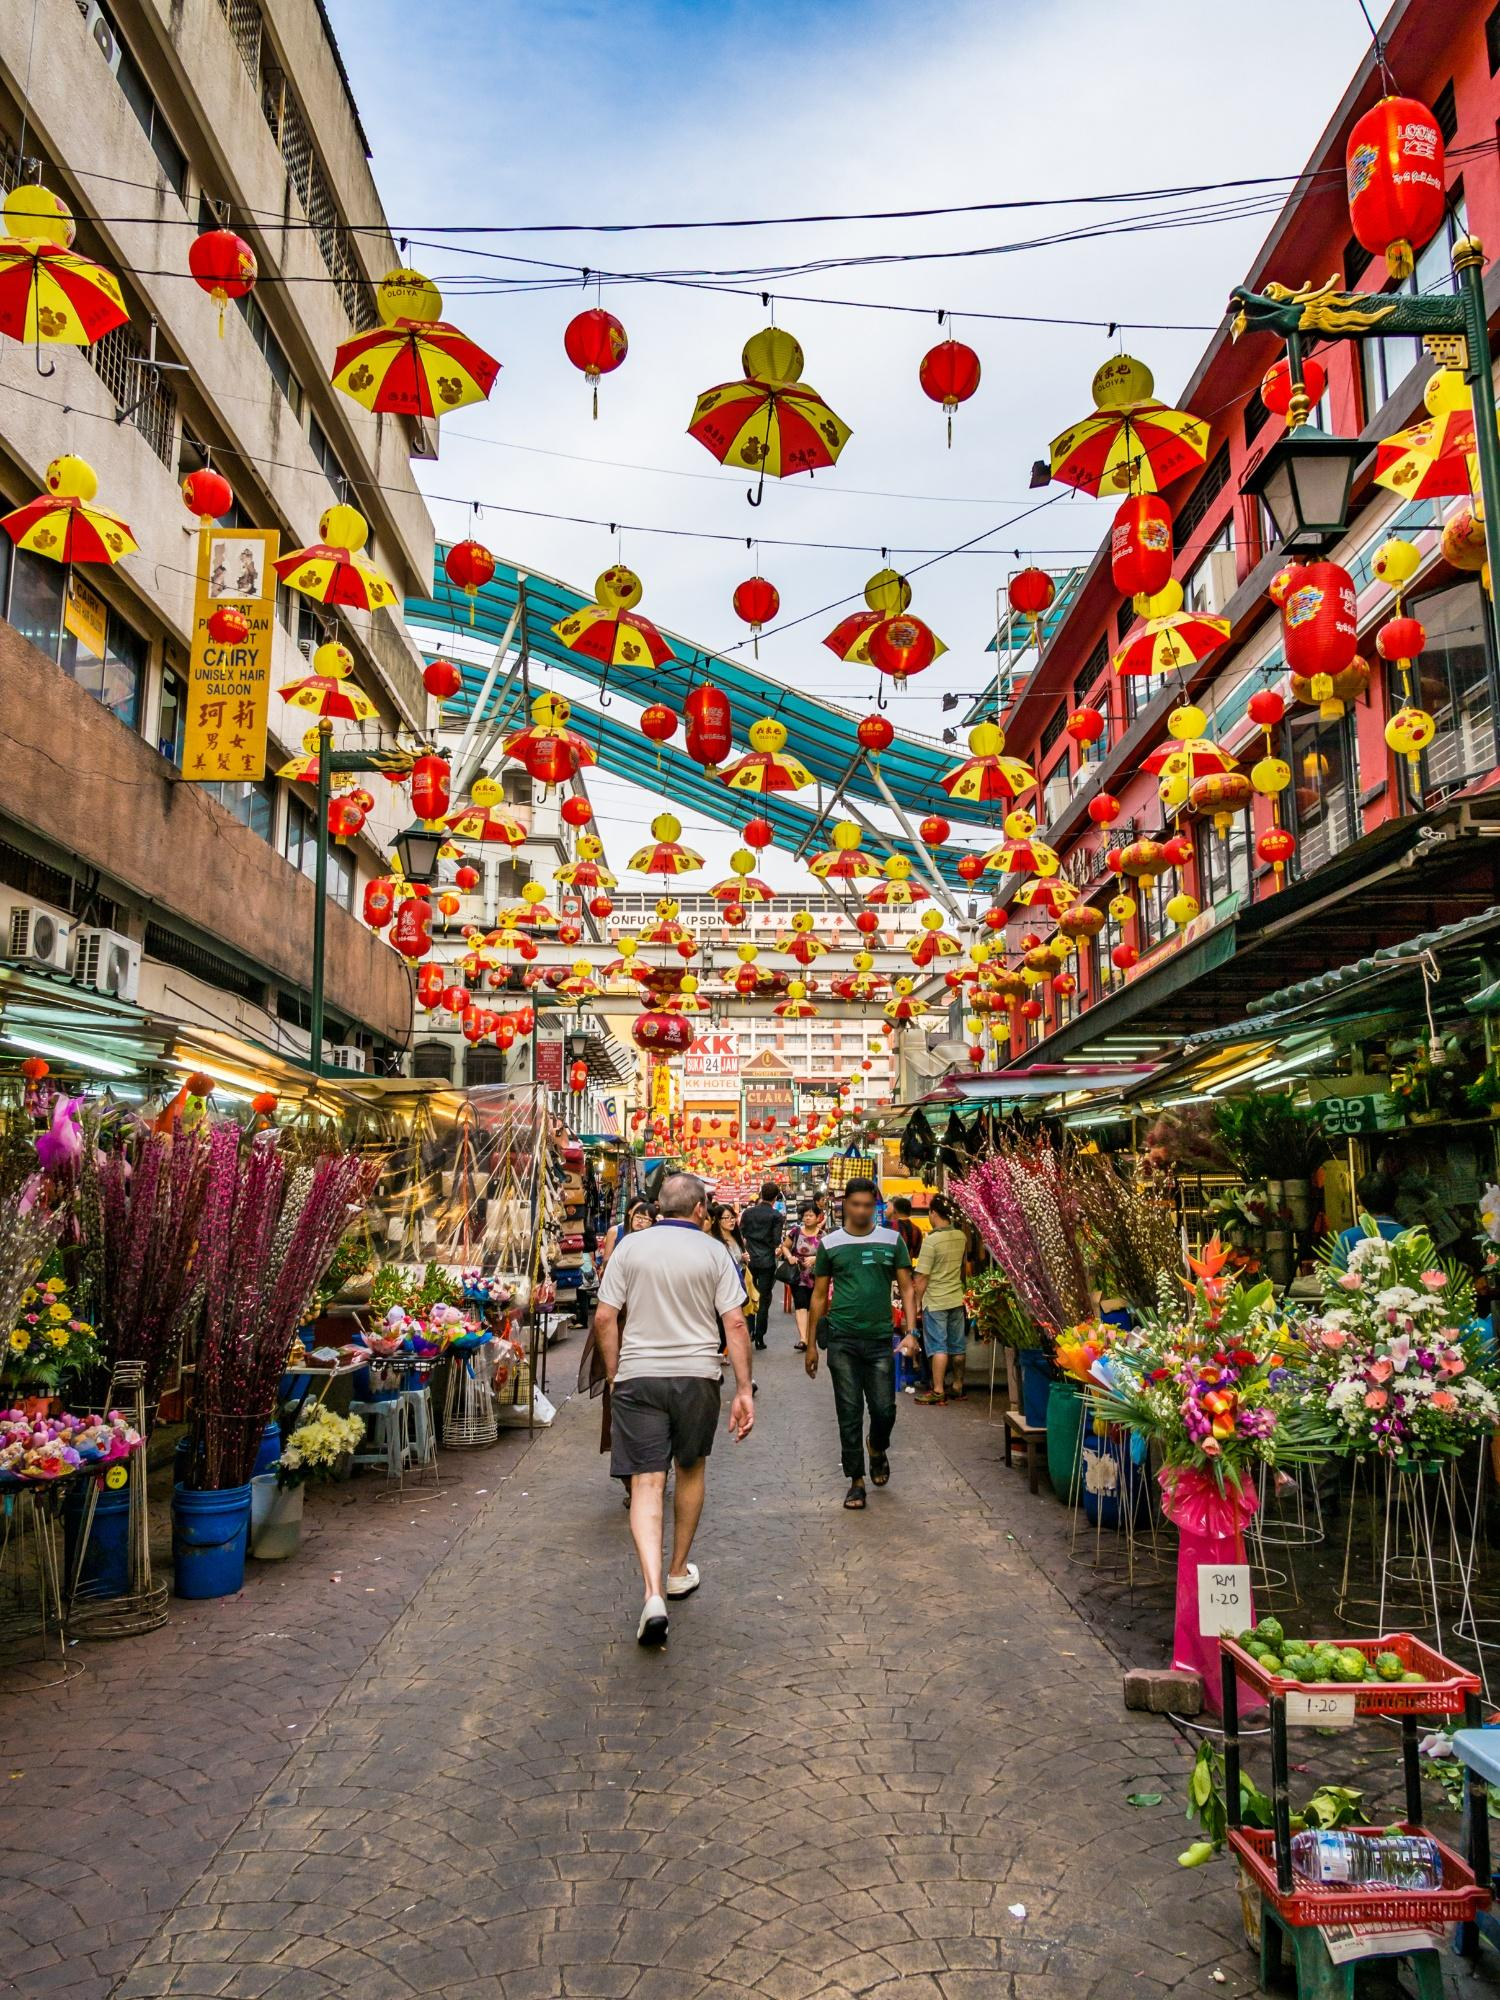Explain the visual content of the image in great detail. The image vividly captures a lively street scene in Bangkok’s Chinatown. The center of the street is bustling with pedestrians, many appearing to be tourists and locals, engaging in their daily activities. Along both sides, numerous vendor stalls are set up, displaying an array of colorful products, predominantly flowers that provide a vibrant splash against the more muted tones of the buildings.

Overhead, the street is festooned with red and yellow lanterns and umbrellas, creating a festive and almost whimsical atmosphere. These decorations are intricately aligned and suspended, stretching across the street and adding a lively canopy that enhances the street's charm. Buildings on either side of the street are multistoried, with the top floors adorned with further decorations and signage in both local scripts and English, indicating the blend of cultural influences. The perspective of the image is from a street level, which offers an immersive view that pulls viewers into the bustling and animated world of this part of Chinatown. 